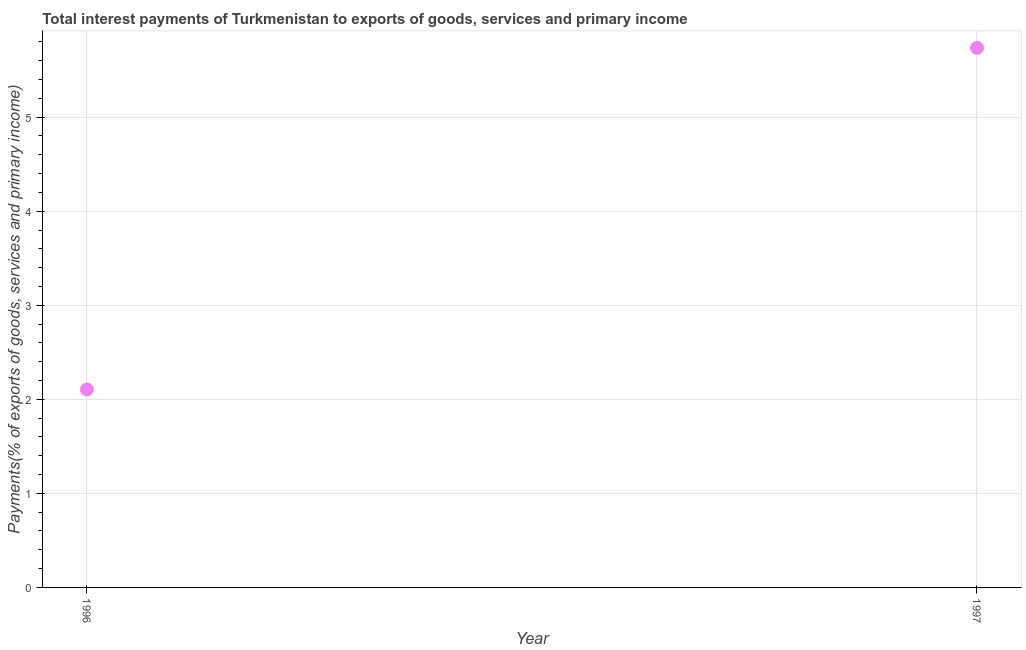What is the total interest payments on external debt in 1997?
Offer a terse response. 5.74. Across all years, what is the maximum total interest payments on external debt?
Your response must be concise. 5.74. Across all years, what is the minimum total interest payments on external debt?
Keep it short and to the point. 2.1. In which year was the total interest payments on external debt maximum?
Your answer should be compact. 1997. In which year was the total interest payments on external debt minimum?
Your response must be concise. 1996. What is the sum of the total interest payments on external debt?
Your answer should be compact. 7.84. What is the difference between the total interest payments on external debt in 1996 and 1997?
Give a very brief answer. -3.63. What is the average total interest payments on external debt per year?
Make the answer very short. 3.92. What is the median total interest payments on external debt?
Offer a very short reply. 3.92. Do a majority of the years between 1997 and 1996 (inclusive) have total interest payments on external debt greater than 3 %?
Your answer should be compact. No. What is the ratio of the total interest payments on external debt in 1996 to that in 1997?
Your response must be concise. 0.37. Is the total interest payments on external debt in 1996 less than that in 1997?
Your answer should be very brief. Yes. In how many years, is the total interest payments on external debt greater than the average total interest payments on external debt taken over all years?
Provide a succinct answer. 1. How many dotlines are there?
Keep it short and to the point. 1. What is the difference between two consecutive major ticks on the Y-axis?
Offer a very short reply. 1. What is the title of the graph?
Give a very brief answer. Total interest payments of Turkmenistan to exports of goods, services and primary income. What is the label or title of the Y-axis?
Your answer should be compact. Payments(% of exports of goods, services and primary income). What is the Payments(% of exports of goods, services and primary income) in 1996?
Make the answer very short. 2.1. What is the Payments(% of exports of goods, services and primary income) in 1997?
Give a very brief answer. 5.74. What is the difference between the Payments(% of exports of goods, services and primary income) in 1996 and 1997?
Offer a very short reply. -3.63. What is the ratio of the Payments(% of exports of goods, services and primary income) in 1996 to that in 1997?
Your response must be concise. 0.37. 